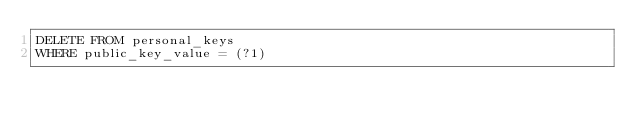<code> <loc_0><loc_0><loc_500><loc_500><_SQL_>DELETE FROM personal_keys
WHERE public_key_value = (?1)
</code> 